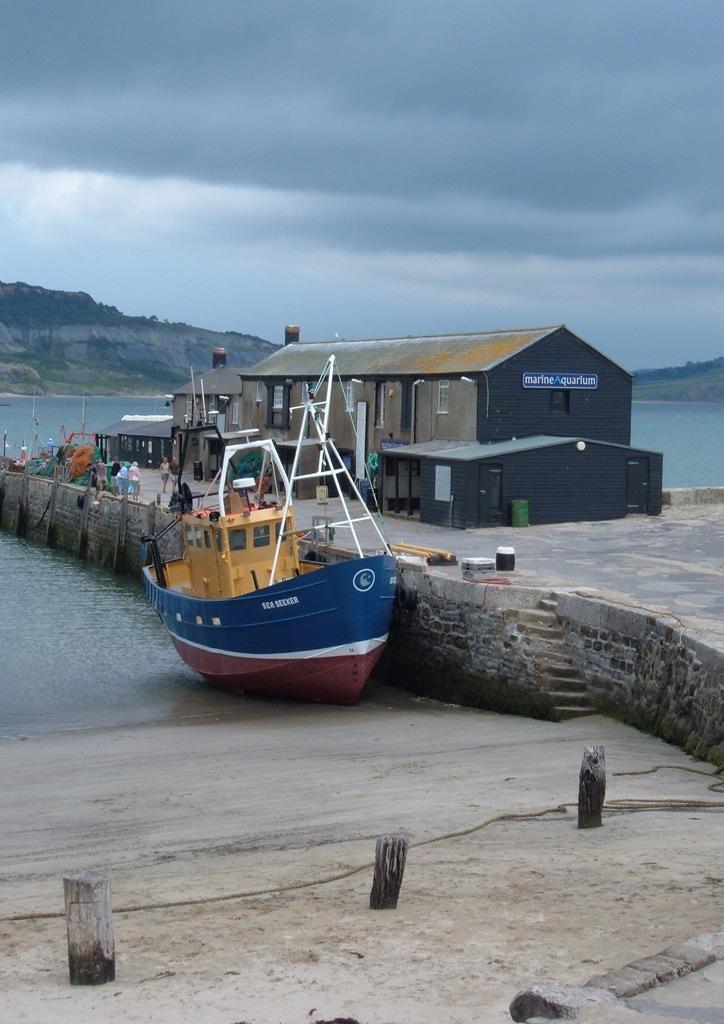Can you describe this image briefly? As we can see in the image there is a boat, water, house, few people here and there, hills, sky and clouds. 